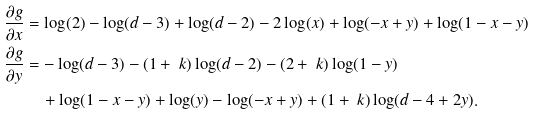Convert formula to latex. <formula><loc_0><loc_0><loc_500><loc_500>\frac { \partial g } { \partial x } & = \log ( 2 ) - \log ( d - 3 ) + \log ( d - 2 ) - 2 \log ( x ) + \log ( - x + y ) + \log ( 1 - x - y ) \\ \frac { \partial g } { \partial y } & = - \log ( d - 3 ) - ( 1 + { \ k } ) \log ( d - 2 ) - ( 2 + { \ k } ) \log ( 1 - y ) \\ & \quad + \log ( 1 - x - y ) + \log ( y ) - \log ( - x + y ) + ( 1 + { \ k } ) \log ( d - 4 + 2 y ) .</formula> 